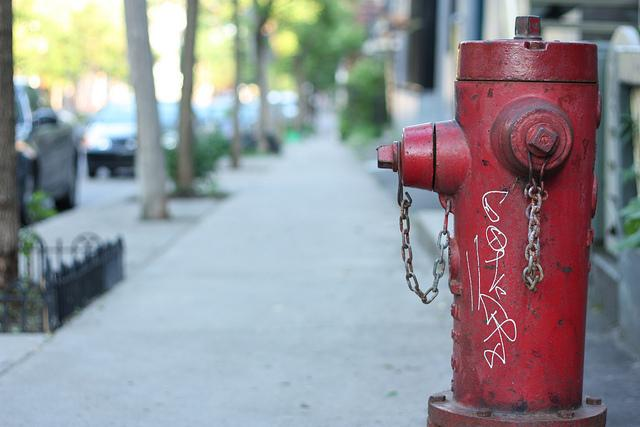Why are there chains on the red thing? security 